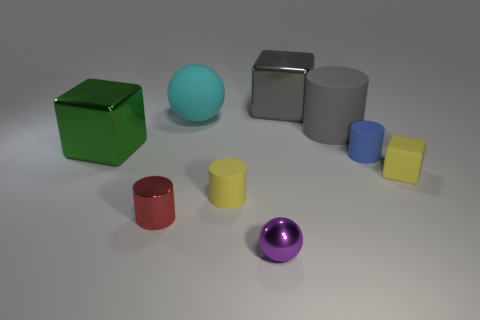Add 1 blue rubber things. How many objects exist? 10 Subtract all cylinders. How many objects are left? 5 Subtract 0 cyan cylinders. How many objects are left? 9 Subtract all big cyan matte spheres. Subtract all gray cylinders. How many objects are left? 7 Add 4 metal things. How many metal things are left? 8 Add 1 purple balls. How many purple balls exist? 2 